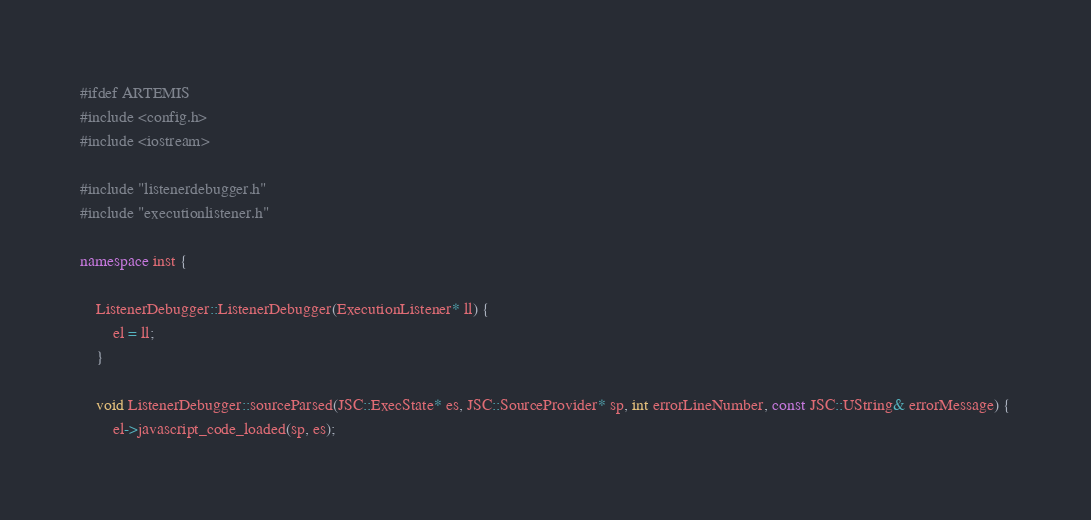Convert code to text. <code><loc_0><loc_0><loc_500><loc_500><_C++_>#ifdef ARTEMIS
#include <config.h>
#include <iostream>

#include "listenerdebugger.h"
#include "executionlistener.h"

namespace inst {

    ListenerDebugger::ListenerDebugger(ExecutionListener* ll) {
        el = ll;
    }

    void ListenerDebugger::sourceParsed(JSC::ExecState* es, JSC::SourceProvider* sp, int errorLineNumber, const JSC::UString& errorMessage) {
        el->javascript_code_loaded(sp, es);</code> 